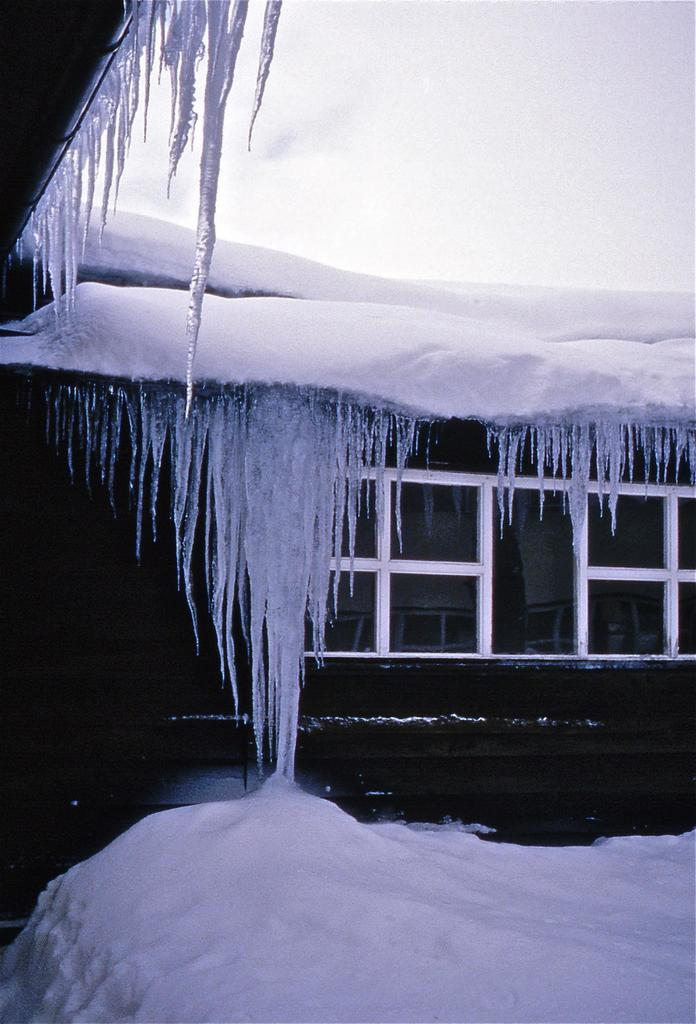What type of weather is depicted in the image? There is snow in the image, indicating cold weather. What architectural features can be seen in the image? There are windows visible in the image. What can be seen in the background of the image? The sky is visible in the background of the image. What type of fiction is being read by the snowman in the image? There is no snowman or any indication of reading in the image. 